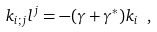<formula> <loc_0><loc_0><loc_500><loc_500>k _ { i ; j } l ^ { j } = - ( \gamma + \gamma ^ { * } ) k _ { i } \ ,</formula> 